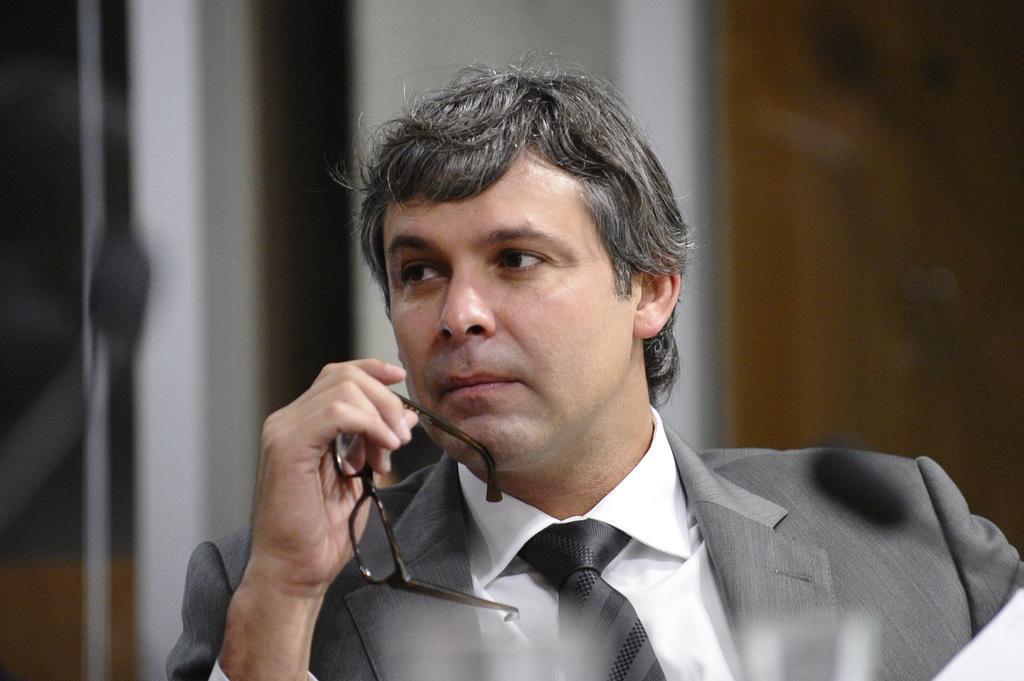Describe this image in one or two sentences. In the picture there is a man holding a spectacle, behind the man there may be a wall. 